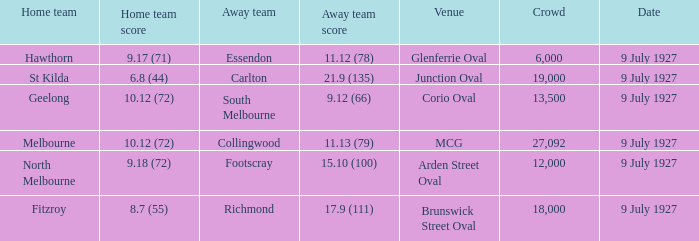How big was the crowd when the away team was Richmond? 18000.0. 